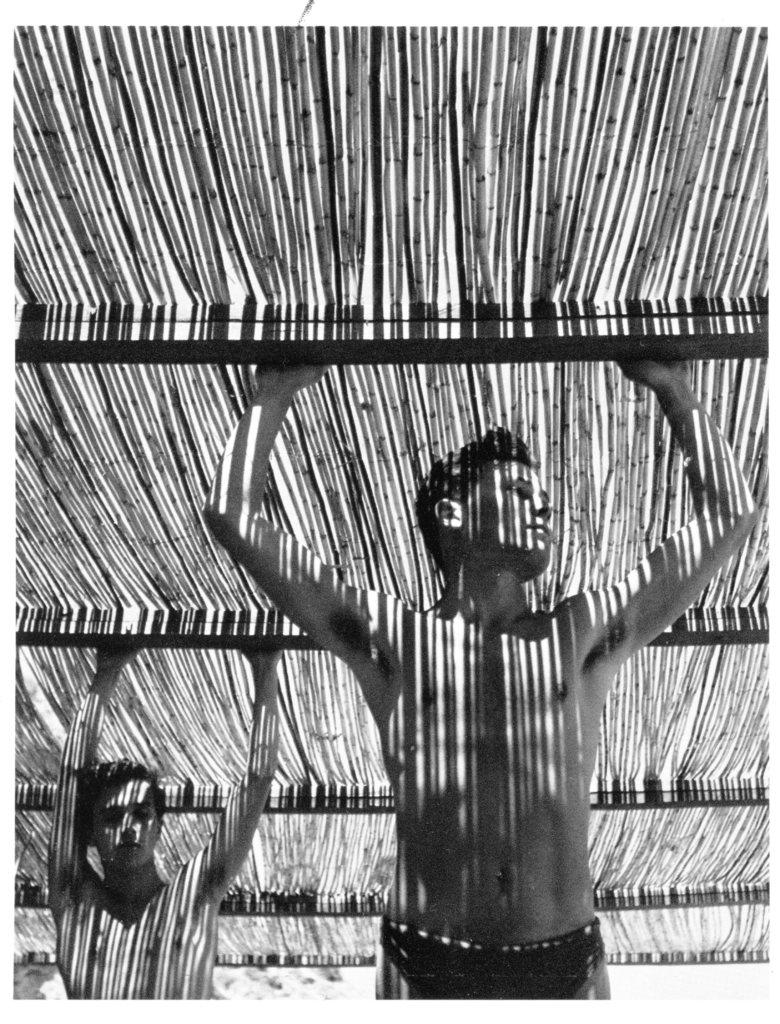What is the color scheme of the image? The image is black and white. How many people are in the image? There are two men in the image. What are the men wearing in the image? The men are not wearing shirts in the image. What can be seen behind the men in the image? The men are standing under a grilled fence in the image. What type of meal is being prepared by the men in the image? There is no indication of a meal being prepared in the image, as the men are not wearing shirts and are standing under a grilled fence. What ornament is hanging from the fence in the image? There is no ornament visible on the fence in the image. 